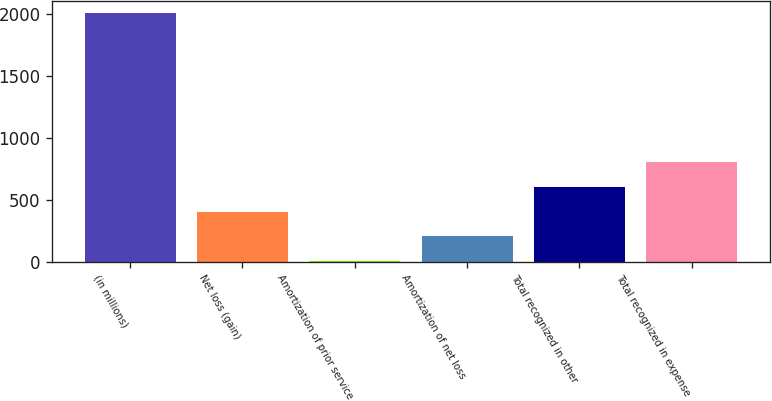<chart> <loc_0><loc_0><loc_500><loc_500><bar_chart><fcel>(in millions)<fcel>Net loss (gain)<fcel>Amortization of prior service<fcel>Amortization of net loss<fcel>Total recognized in other<fcel>Total recognized in expense<nl><fcel>2008<fcel>403.2<fcel>2<fcel>202.6<fcel>603.8<fcel>804.4<nl></chart> 